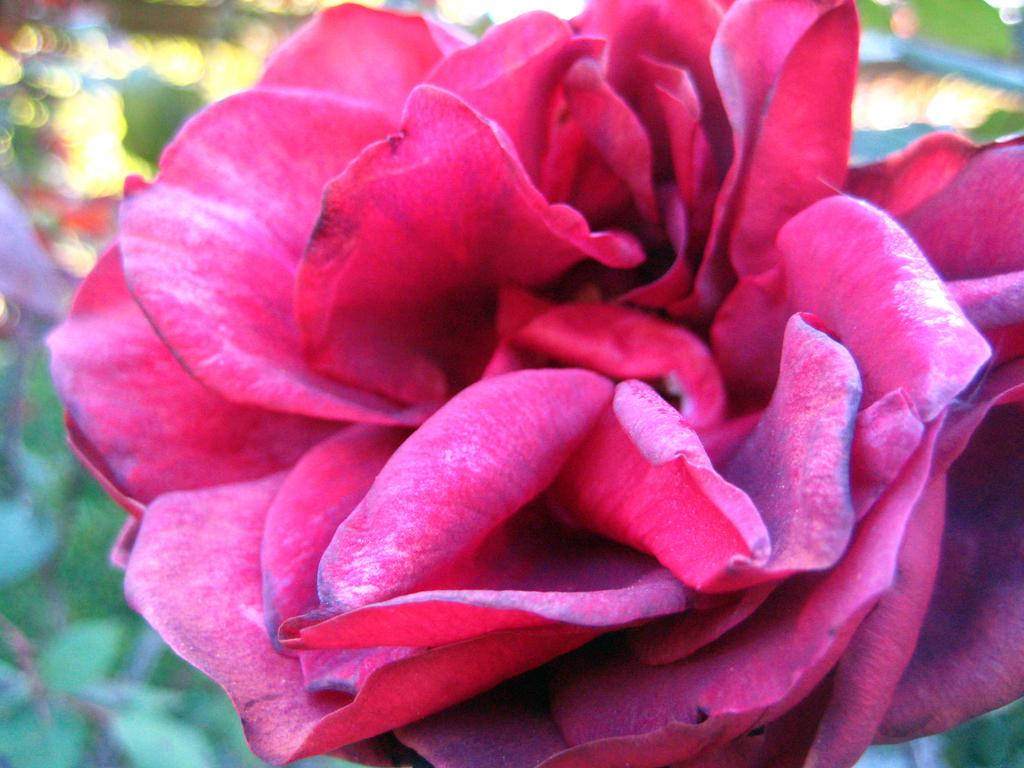What is the main subject of the image? There is a flower in the image. Can you describe the background of the image? The background of the image is blurred. How many knots are tied on the flower in the image? There are no knots present on the flower in the image. What unit of measurement is used to determine the size of the flower in the image? The size of the flower in the image cannot be determined by a unit of measurement, as the image does not provide a reference for scale. 